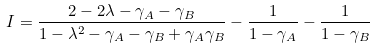<formula> <loc_0><loc_0><loc_500><loc_500>I = \frac { 2 - 2 \lambda - \gamma _ { A } - \gamma _ { B } } { 1 - \lambda ^ { 2 } - \gamma _ { A } - \gamma _ { B } + \gamma _ { A } \gamma _ { B } } - \frac { 1 } { 1 - \gamma _ { A } } - \frac { 1 } { 1 - \gamma _ { B } }</formula> 